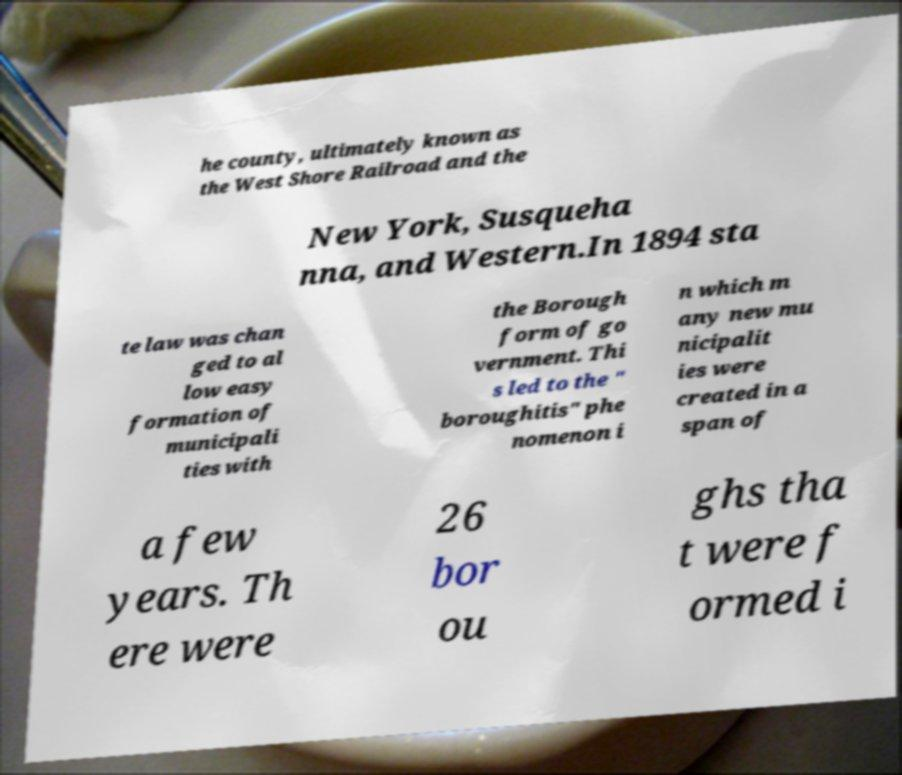Could you assist in decoding the text presented in this image and type it out clearly? he county, ultimately known as the West Shore Railroad and the New York, Susqueha nna, and Western.In 1894 sta te law was chan ged to al low easy formation of municipali ties with the Borough form of go vernment. Thi s led to the " boroughitis" phe nomenon i n which m any new mu nicipalit ies were created in a span of a few years. Th ere were 26 bor ou ghs tha t were f ormed i 